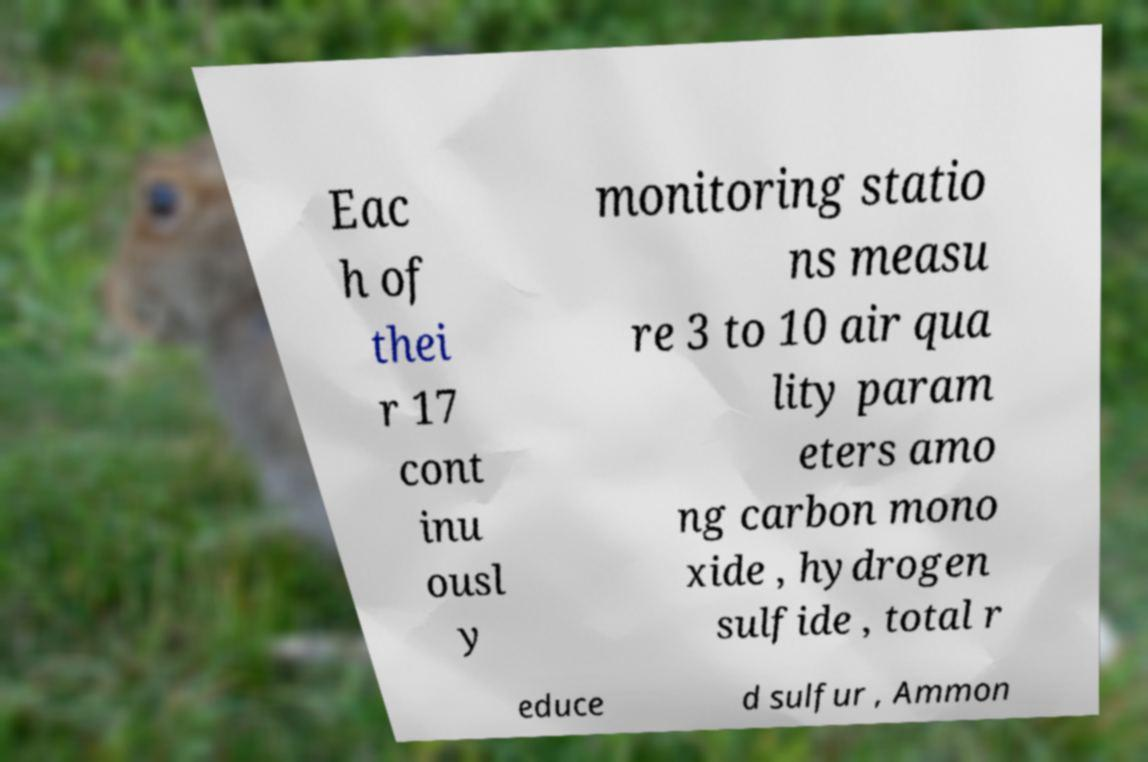Please identify and transcribe the text found in this image. Eac h of thei r 17 cont inu ousl y monitoring statio ns measu re 3 to 10 air qua lity param eters amo ng carbon mono xide , hydrogen sulfide , total r educe d sulfur , Ammon 